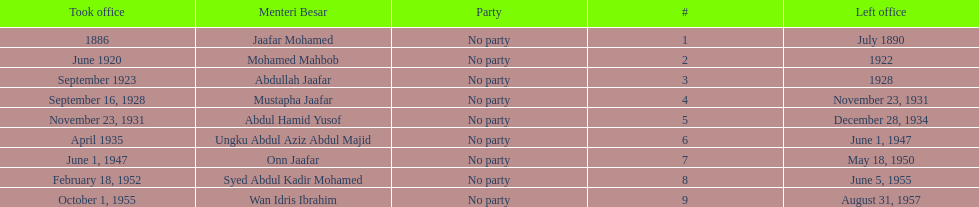What was the duration of ungku abdul aziz abdul majid's tenure? 12 years. 